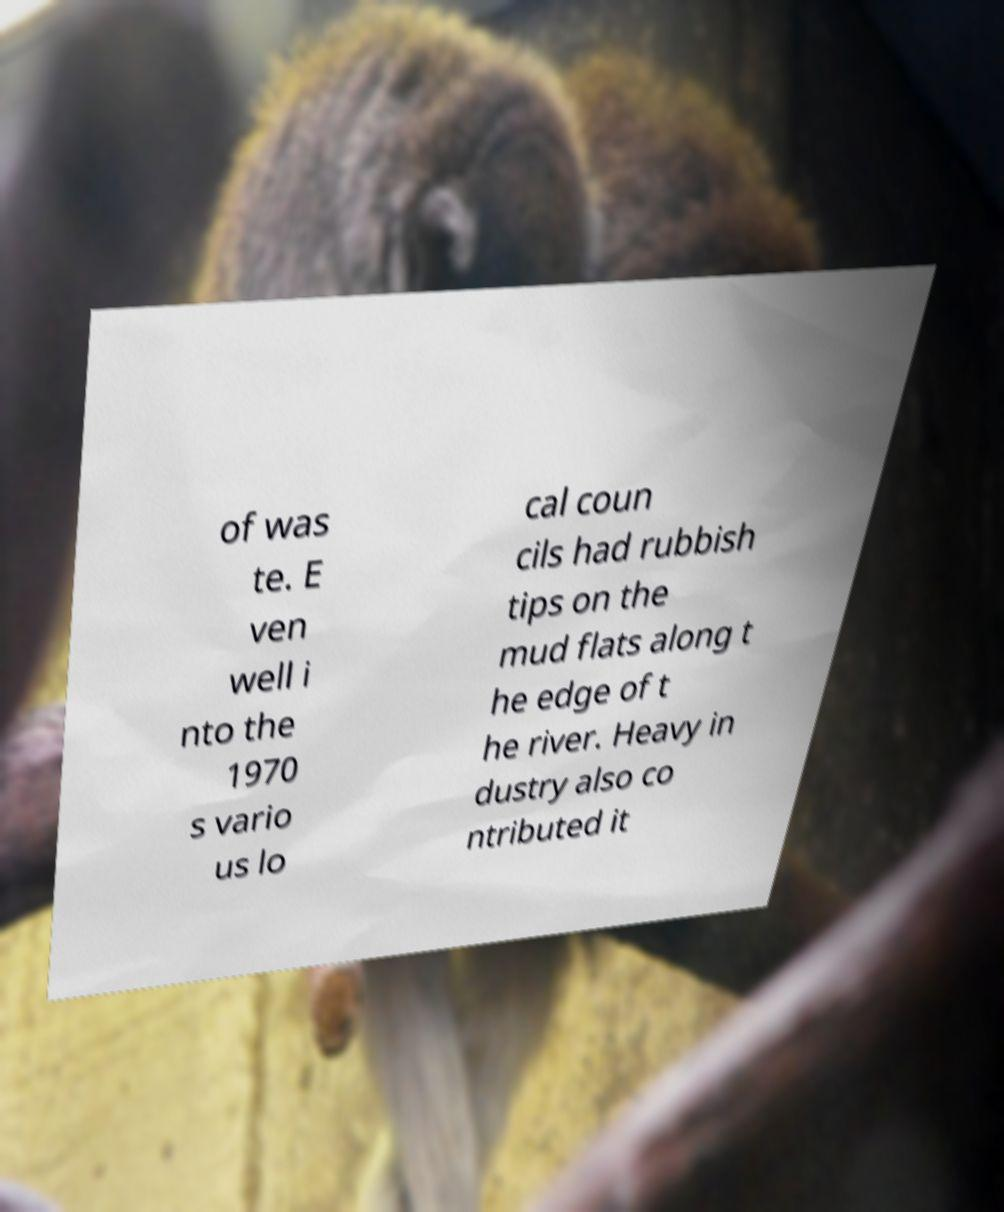Can you accurately transcribe the text from the provided image for me? of was te. E ven well i nto the 1970 s vario us lo cal coun cils had rubbish tips on the mud flats along t he edge of t he river. Heavy in dustry also co ntributed it 